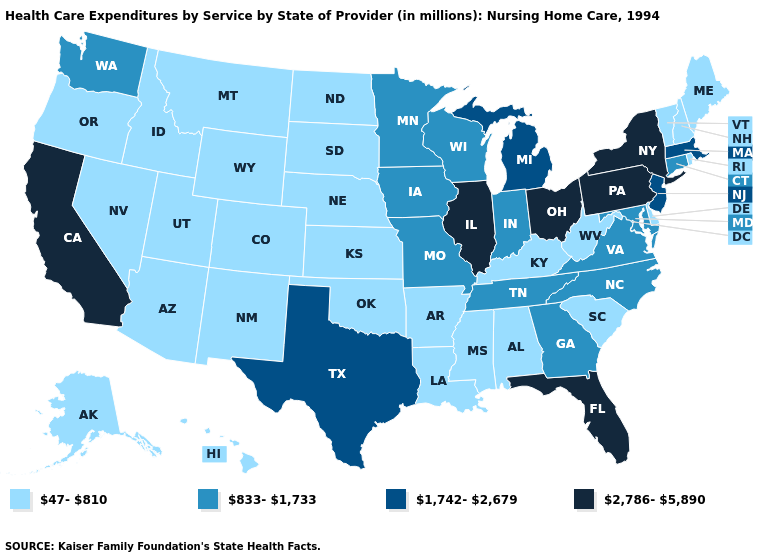Among the states that border Kansas , does Missouri have the lowest value?
Quick response, please. No. Is the legend a continuous bar?
Keep it brief. No. Which states have the lowest value in the USA?
Give a very brief answer. Alabama, Alaska, Arizona, Arkansas, Colorado, Delaware, Hawaii, Idaho, Kansas, Kentucky, Louisiana, Maine, Mississippi, Montana, Nebraska, Nevada, New Hampshire, New Mexico, North Dakota, Oklahoma, Oregon, Rhode Island, South Carolina, South Dakota, Utah, Vermont, West Virginia, Wyoming. What is the lowest value in the USA?
Short answer required. 47-810. Which states have the lowest value in the USA?
Keep it brief. Alabama, Alaska, Arizona, Arkansas, Colorado, Delaware, Hawaii, Idaho, Kansas, Kentucky, Louisiana, Maine, Mississippi, Montana, Nebraska, Nevada, New Hampshire, New Mexico, North Dakota, Oklahoma, Oregon, Rhode Island, South Carolina, South Dakota, Utah, Vermont, West Virginia, Wyoming. How many symbols are there in the legend?
Answer briefly. 4. Is the legend a continuous bar?
Be succinct. No. Name the states that have a value in the range 47-810?
Answer briefly. Alabama, Alaska, Arizona, Arkansas, Colorado, Delaware, Hawaii, Idaho, Kansas, Kentucky, Louisiana, Maine, Mississippi, Montana, Nebraska, Nevada, New Hampshire, New Mexico, North Dakota, Oklahoma, Oregon, Rhode Island, South Carolina, South Dakota, Utah, Vermont, West Virginia, Wyoming. What is the value of Colorado?
Write a very short answer. 47-810. Among the states that border Alabama , does Mississippi have the lowest value?
Write a very short answer. Yes. What is the value of North Dakota?
Keep it brief. 47-810. Does the first symbol in the legend represent the smallest category?
Answer briefly. Yes. Name the states that have a value in the range 1,742-2,679?
Keep it brief. Massachusetts, Michigan, New Jersey, Texas. What is the value of Connecticut?
Give a very brief answer. 833-1,733. How many symbols are there in the legend?
Quick response, please. 4. 